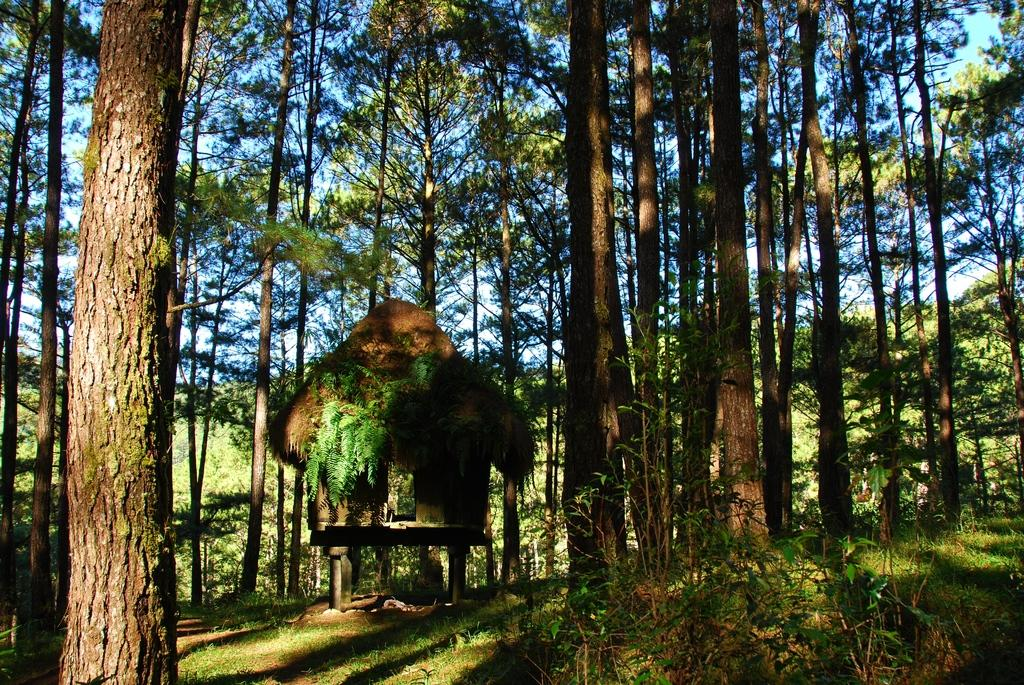What type of vegetation is present in the image? There are green trees in the image. What type of structure can be seen in the image? There is a hut in the image. What colors are visible in the sky in the image? The sky is blue and white in color. What type of attraction is present in the image? There is no attraction mentioned or visible in the image. How many women are present in the image? There is no mention or indication of any women in the image. 